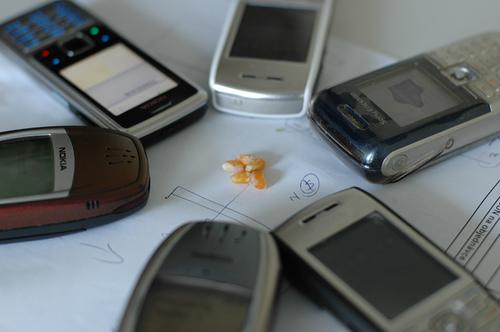What does the item in the middle of the phones look like? Please explain your reasoning. jelly beans. There are bean like items in the middle. 